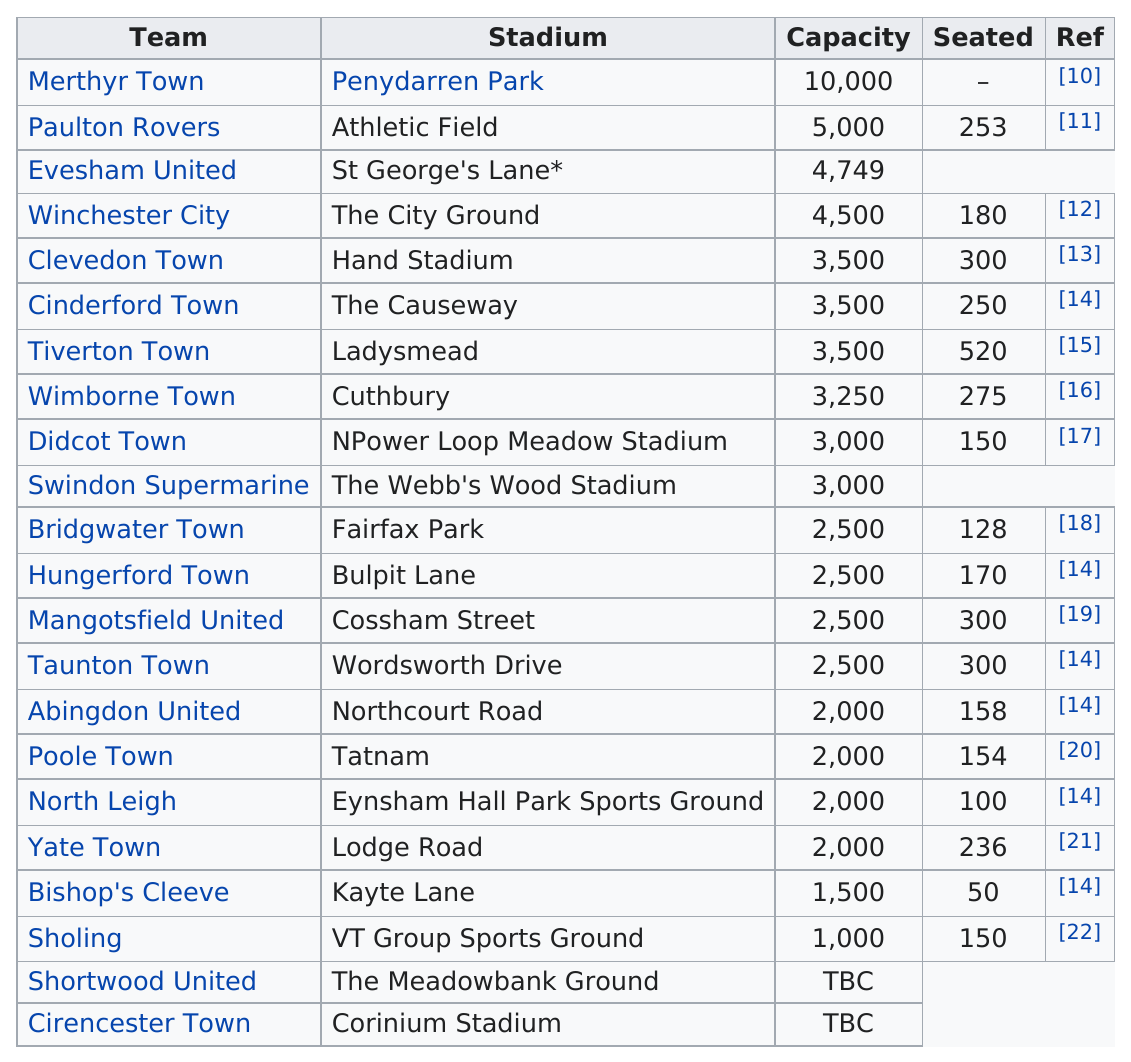Indicate a few pertinent items in this graphic. There were 22 teams in the 2012-13 Southern League Division One South & West. There are approximately 2,500 seats located in Fairfax Park. The total number of seating for Yate Town is 2,000. Penydarren Park has a capacity of 6,500, while Hand Stadium has a capacity of 2,000. The VT Group Sports Ground has the smallest capacity of any stadium. 